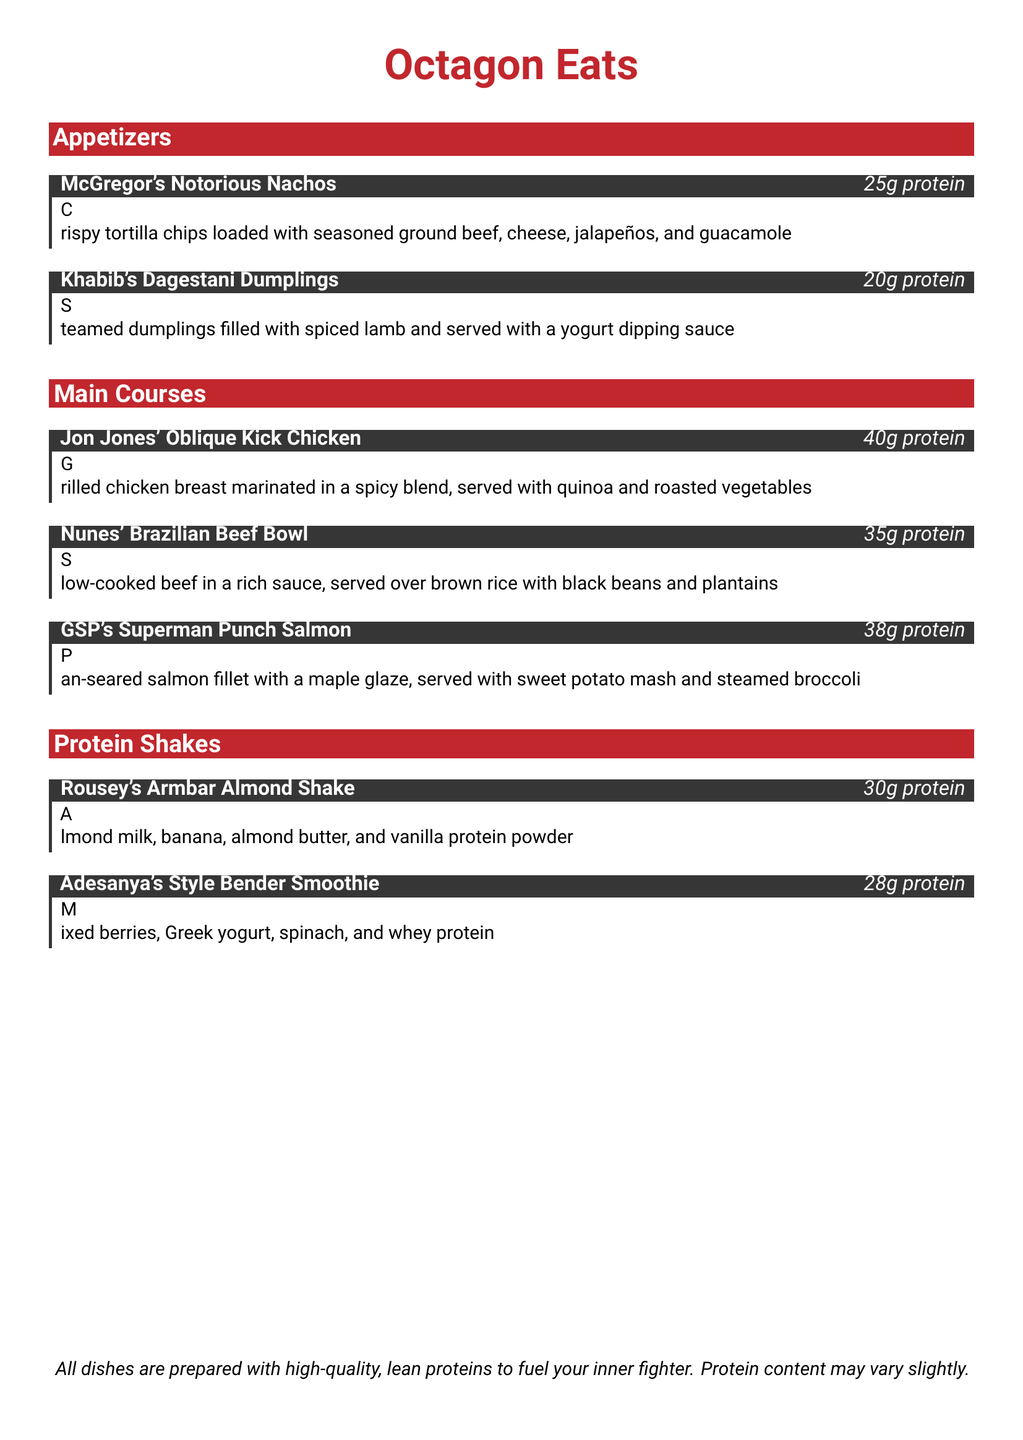What is the name of the appetizer inspired by McGregor? The appetizer is titled "McGregor's Notorious Nachos".
Answer: McGregor's Notorious Nachos How much protein is in Khabib's Dagestani Dumplings? The protein content of Khabib's Dagestani Dumplings is specified in the menu.
Answer: 20g protein Which main course features salmon? The main course that features salmon is named "GSP's Superman Punch Salmon".
Answer: GSP's Superman Punch Salmon What is the protein content of Rousey's Armbar Almond Shake? The protein content for Rousey's Armbar Almond Shake is listed in the menu.
Answer: 30g protein Which dish has the highest protein content? To determine this, compare the protein values listed for each dish in the menu.
Answer: Jon Jones' Oblique Kick Chicken What are the main ingredients in Adesanya's Style Bender Smoothie? The ingredients are mixed berries, Greek yogurt, spinach, and whey protein, as listed in the menu.
Answer: Mixed berries, Greek yogurt, spinach, and whey protein What type of restaurant menu is this? The menu type is a themed protein-packed menu inspired by famous MMA fighters.
Answer: Themed protein-packed menu How many grams of protein does Nunes' Brazilian Beef Bowl have? The protein information for Nunes' Brazilian Beef Bowl is included in the menu.
Answer: 35g protein 